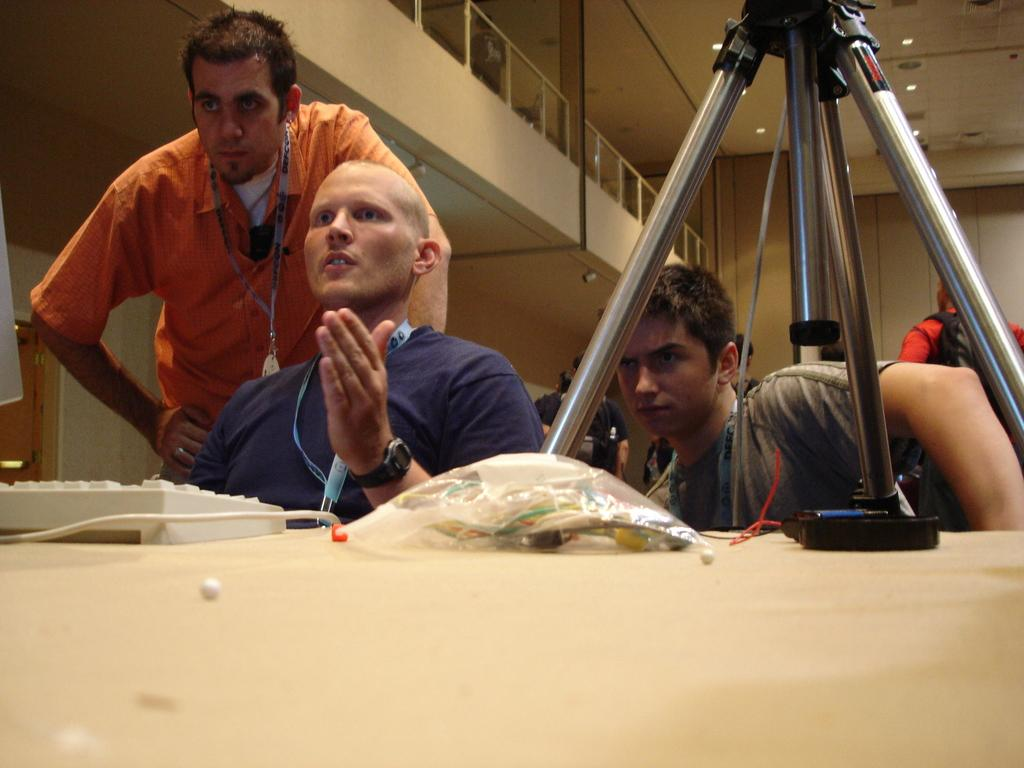What is located in the foreground of the image? There is a table in the foreground of the image. What is on the table? There is a stand on the table, and other objects are present on the table. Who can be seen in the image? There are people behind the table. What is visible at the top of the image? The roof is visible at the top of the image. Can you see a rat running across the table in the image? No, there is no rat present in the image. What type of store is being represented by the table and objects in the image? The image does not depict a store; it is a table with a stand and other objects on it, with people behind it. 